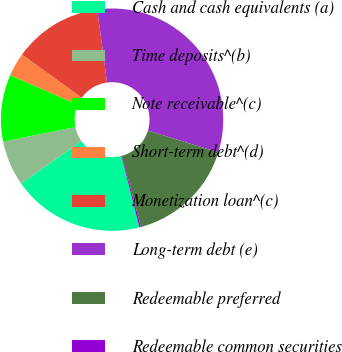Convert chart to OTSL. <chart><loc_0><loc_0><loc_500><loc_500><pie_chart><fcel>Cash and cash equivalents (a)<fcel>Time deposits^(b)<fcel>Note receivable^(c)<fcel>Short-term debt^(d)<fcel>Monetization loan^(c)<fcel>Long-term debt (e)<fcel>Redeemable preferred<fcel>Redeemable common securities<nl><fcel>19.23%<fcel>6.56%<fcel>9.73%<fcel>3.4%<fcel>12.9%<fcel>31.89%<fcel>16.06%<fcel>0.23%<nl></chart> 